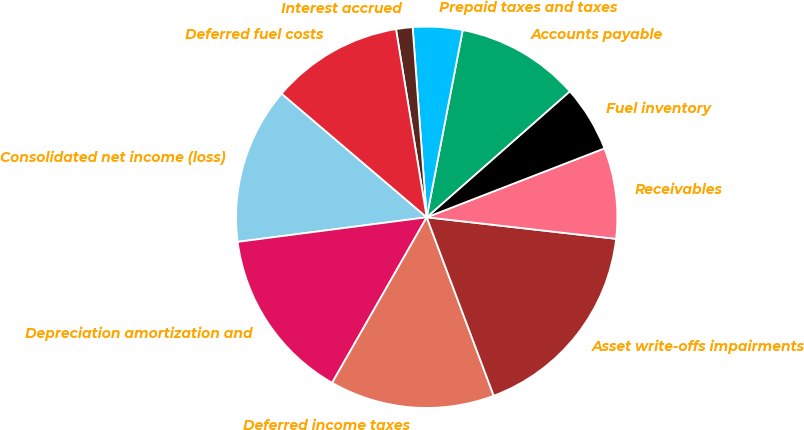Convert chart to OTSL. <chart><loc_0><loc_0><loc_500><loc_500><pie_chart><fcel>Consolidated net income (loss)<fcel>Depreciation amortization and<fcel>Deferred income taxes<fcel>Asset write-offs impairments<fcel>Receivables<fcel>Fuel inventory<fcel>Accounts payable<fcel>Prepaid taxes and taxes<fcel>Interest accrued<fcel>Deferred fuel costs<nl><fcel>13.29%<fcel>14.68%<fcel>13.98%<fcel>17.48%<fcel>7.69%<fcel>5.6%<fcel>10.49%<fcel>4.2%<fcel>1.4%<fcel>11.19%<nl></chart> 